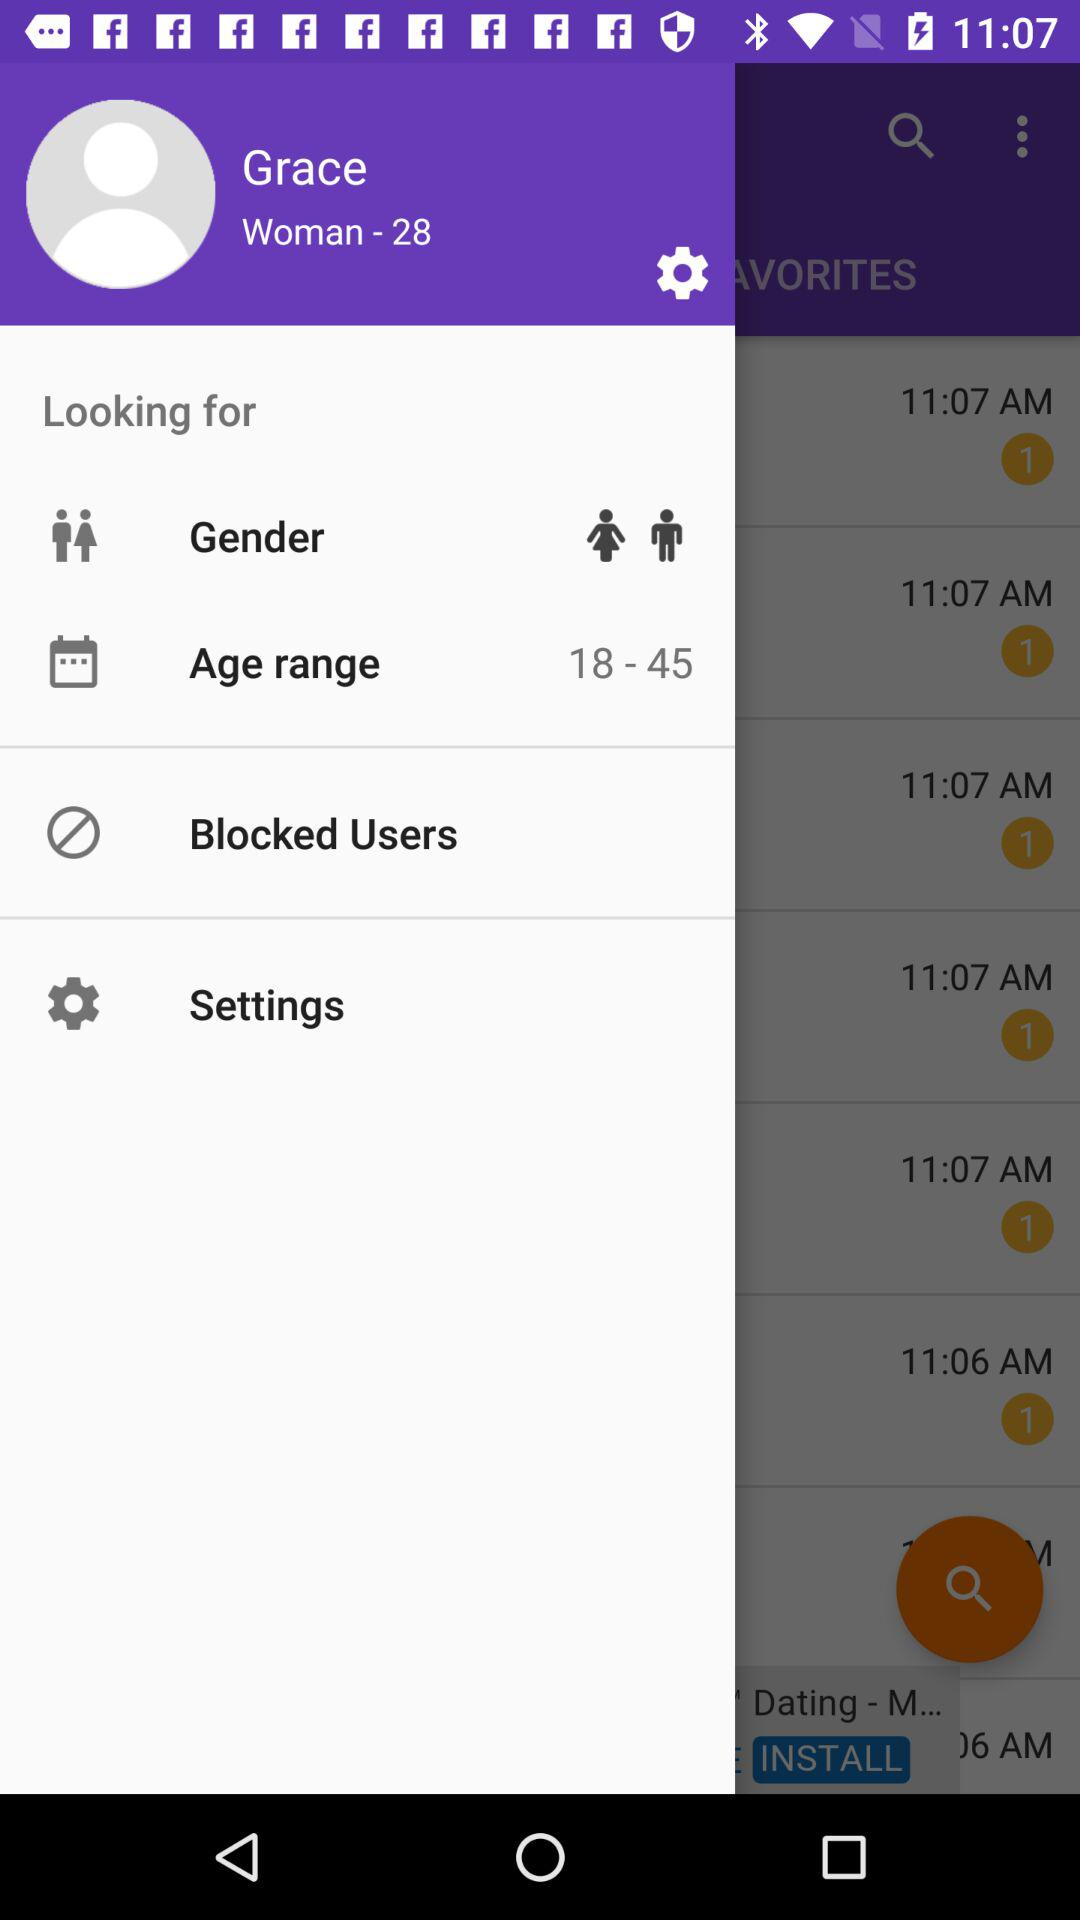What is the age of women? The age is 28. 